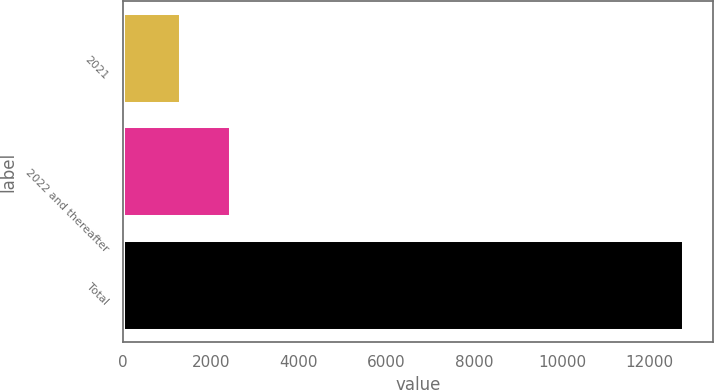Convert chart. <chart><loc_0><loc_0><loc_500><loc_500><bar_chart><fcel>2021<fcel>2022 and thereafter<fcel>Total<nl><fcel>1318<fcel>2465.2<fcel>12790<nl></chart> 